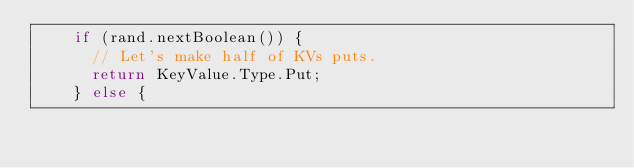<code> <loc_0><loc_0><loc_500><loc_500><_Java_>    if (rand.nextBoolean()) {
      // Let's make half of KVs puts.
      return KeyValue.Type.Put;
    } else {</code> 